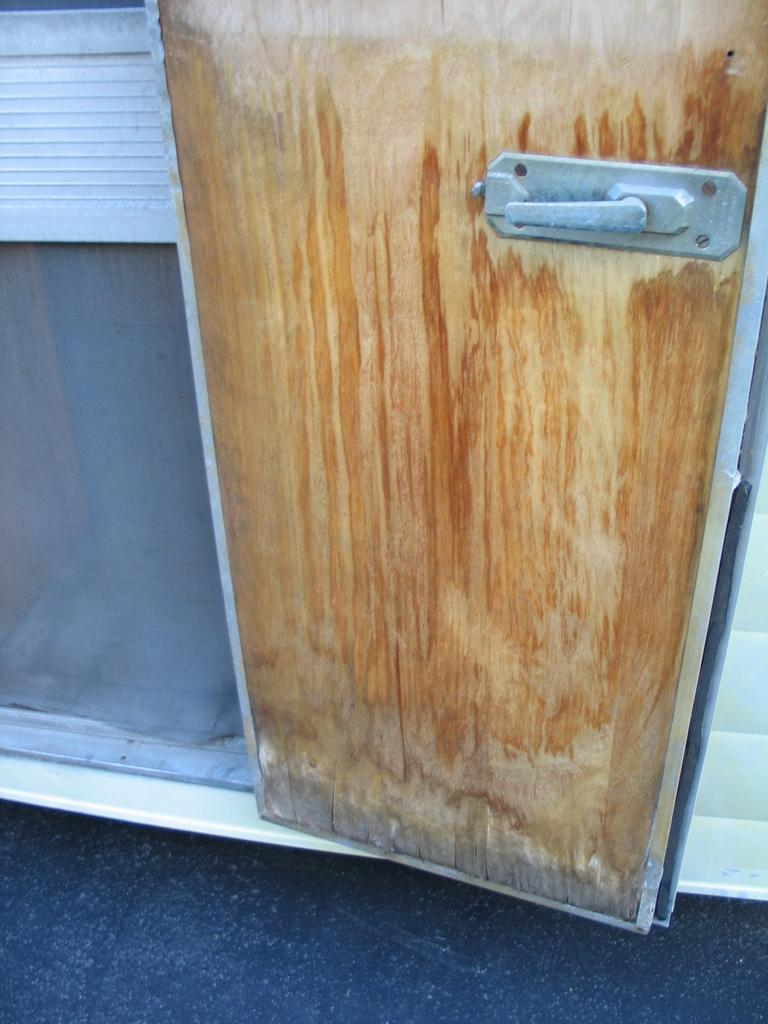What is present in the image that people typically use to enter or exit a space? There is a door in the image. Can you describe a specific feature of the door handle? The door handle resembles that of a vehicle. What type of class is being held in the image? There is no class present in the image; it only features a door with a vehicle-like door handle. What record is being set or broken in the image? There is no record being set or broken in the image; it only features a door with a vehicle-like door handle. 